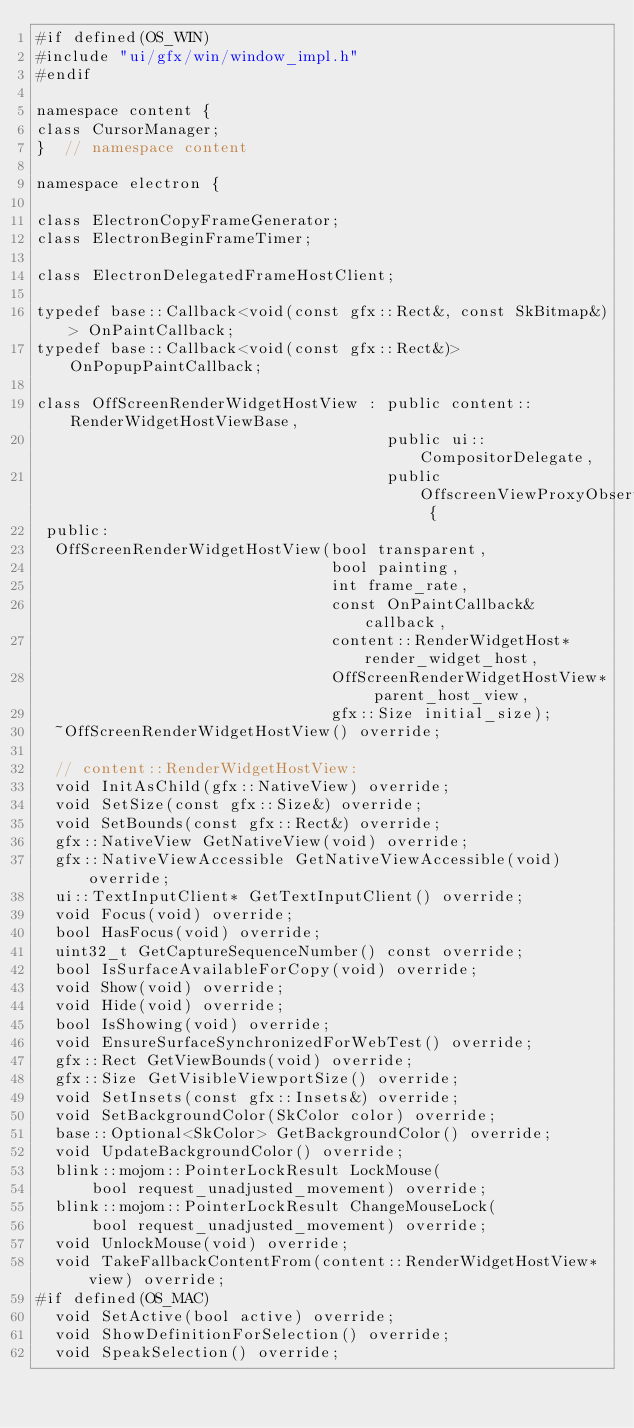<code> <loc_0><loc_0><loc_500><loc_500><_C_>#if defined(OS_WIN)
#include "ui/gfx/win/window_impl.h"
#endif

namespace content {
class CursorManager;
}  // namespace content

namespace electron {

class ElectronCopyFrameGenerator;
class ElectronBeginFrameTimer;

class ElectronDelegatedFrameHostClient;

typedef base::Callback<void(const gfx::Rect&, const SkBitmap&)> OnPaintCallback;
typedef base::Callback<void(const gfx::Rect&)> OnPopupPaintCallback;

class OffScreenRenderWidgetHostView : public content::RenderWidgetHostViewBase,
                                      public ui::CompositorDelegate,
                                      public OffscreenViewProxyObserver {
 public:
  OffScreenRenderWidgetHostView(bool transparent,
                                bool painting,
                                int frame_rate,
                                const OnPaintCallback& callback,
                                content::RenderWidgetHost* render_widget_host,
                                OffScreenRenderWidgetHostView* parent_host_view,
                                gfx::Size initial_size);
  ~OffScreenRenderWidgetHostView() override;

  // content::RenderWidgetHostView:
  void InitAsChild(gfx::NativeView) override;
  void SetSize(const gfx::Size&) override;
  void SetBounds(const gfx::Rect&) override;
  gfx::NativeView GetNativeView(void) override;
  gfx::NativeViewAccessible GetNativeViewAccessible(void) override;
  ui::TextInputClient* GetTextInputClient() override;
  void Focus(void) override;
  bool HasFocus(void) override;
  uint32_t GetCaptureSequenceNumber() const override;
  bool IsSurfaceAvailableForCopy(void) override;
  void Show(void) override;
  void Hide(void) override;
  bool IsShowing(void) override;
  void EnsureSurfaceSynchronizedForWebTest() override;
  gfx::Rect GetViewBounds(void) override;
  gfx::Size GetVisibleViewportSize() override;
  void SetInsets(const gfx::Insets&) override;
  void SetBackgroundColor(SkColor color) override;
  base::Optional<SkColor> GetBackgroundColor() override;
  void UpdateBackgroundColor() override;
  blink::mojom::PointerLockResult LockMouse(
      bool request_unadjusted_movement) override;
  blink::mojom::PointerLockResult ChangeMouseLock(
      bool request_unadjusted_movement) override;
  void UnlockMouse(void) override;
  void TakeFallbackContentFrom(content::RenderWidgetHostView* view) override;
#if defined(OS_MAC)
  void SetActive(bool active) override;
  void ShowDefinitionForSelection() override;
  void SpeakSelection() override;</code> 